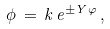Convert formula to latex. <formula><loc_0><loc_0><loc_500><loc_500>\phi \, = \, k \, e ^ { \pm Y \varphi } \, ,</formula> 